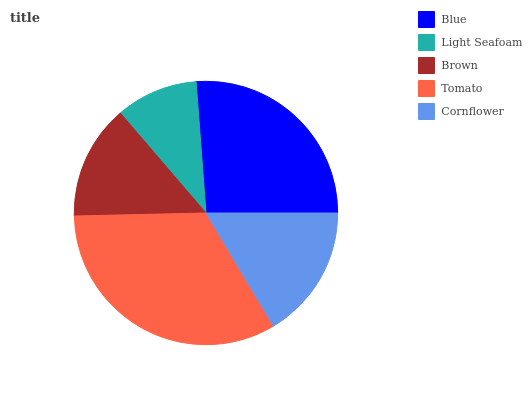Is Light Seafoam the minimum?
Answer yes or no. Yes. Is Tomato the maximum?
Answer yes or no. Yes. Is Brown the minimum?
Answer yes or no. No. Is Brown the maximum?
Answer yes or no. No. Is Brown greater than Light Seafoam?
Answer yes or no. Yes. Is Light Seafoam less than Brown?
Answer yes or no. Yes. Is Light Seafoam greater than Brown?
Answer yes or no. No. Is Brown less than Light Seafoam?
Answer yes or no. No. Is Cornflower the high median?
Answer yes or no. Yes. Is Cornflower the low median?
Answer yes or no. Yes. Is Blue the high median?
Answer yes or no. No. Is Brown the low median?
Answer yes or no. No. 